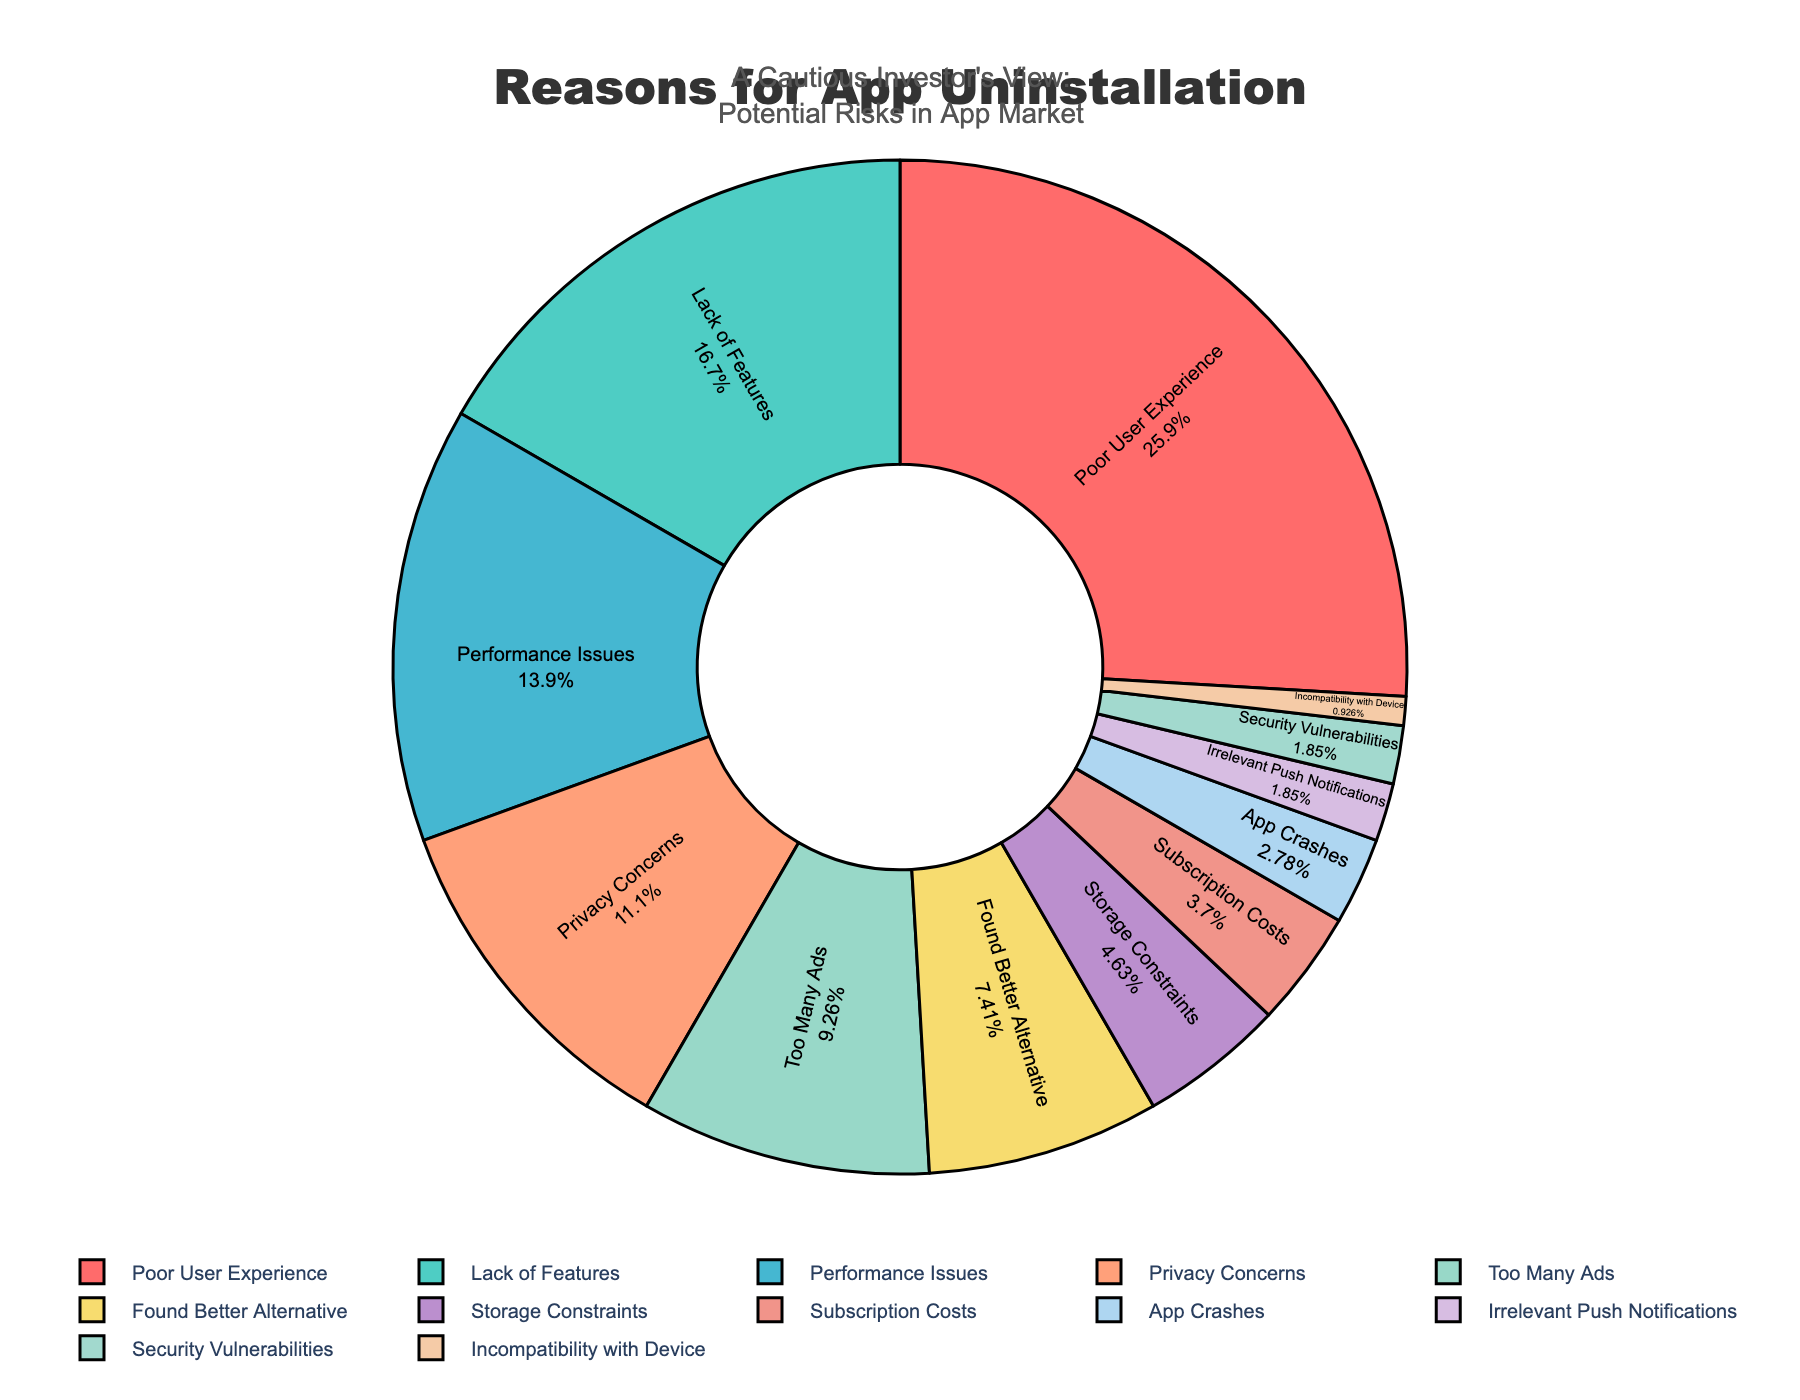What percentage of app uninstallations are due to Poor User Experience? Locate the segment labeled "Poor User Experience" on the pie chart. The percentage inside this segment is the answer.
Answer: 28% What is the combined percentage of uninstallations due to Lack of Features and Performance Issues? Identify the percentages for "Lack of Features" and "Performance Issues" in the pie chart. Sum these percentages: 18% + 15%.
Answer: 33% Which reasons together account for more than 50% of the uninstallations? Identify the larger segments and sum their percentages sequentially until the total exceeds 50%. "Poor User Experience" (28%), "Lack of Features" (18%), and "Performance Issues" (15%) together account for 61%.
Answer: Poor User Experience, Lack of Features, Performance Issues Which reason accounts for the smallest percentage of app uninstallations? Locate the smallest segment on the pie chart. The label inside this segment will indicate the reason.
Answer: Incompatibility with Device How many reasons each have a percentage of 10% or more? Count the segments in the pie chart whose labels indicate percentages of 10% or higher. The reasons are "Poor User Experience" (28%), "Lack of Features" (18%), "Performance Issues" (15%), and "Privacy Concerns" (12%).
Answer: 4 Is the percentage of uninstallations due to Security Vulnerabilities greater than that of Irrelevant Push Notifications? Compare the percentages for "Security Vulnerabilities" and "Irrelevant Push Notifications" in the pie chart. Both have the same percentage, 2%.
Answer: No Do the reasons "Too Many Ads" and "Found Better Alternative" together account for more uninstallations than "Poor User Experience"? Sum the percentages for "Too Many Ads" (10%) and "Found Better Alternative" (8%). Compare this total (10% + 8% = 18%) to the percentage for "Poor User Experience" (28%).
Answer: No What is the second most common reason for app uninstallations? Identify the segment with the second largest percentage after "Poor User Experience" (28%). The segment "Lack of Features" with 18% is the second largest.
Answer: Lack of Features What percentage of uninstallations are due to App Crashes, Irrelevant Push Notifications, and Security Vulnerabilities combined? Sum the percentages for App Crashes (3%), Irrelevant Push Notifications (2%), and Security Vulnerabilities (2%): 3% + 2% + 2%.
Answer: 7% Which reasons together account for exactly 25% of the uninstallations? Identify and sum the smaller percentages until the total is exactly 25%. "Storage Constraints" (5%), "Subscription Costs" (4%), "App Crashes" (3%), "Irrelevant Push Notifications" (2%), "Security Vulnerabilities" (2%), and "Incompatibility with Device" (1%) together account for 17%. Add "Found Better Alternative" (8%) to reach exactly 25%.
Answer: Found Better Alternative, Storage Constraints, Subscription Costs, App Crashes, Irrelevant Push Notifications, Security Vulnerabilities, Incompatibility with Device 